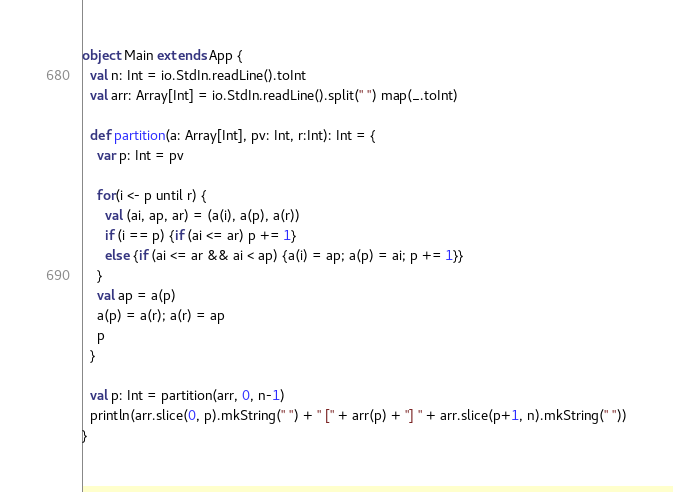Convert code to text. <code><loc_0><loc_0><loc_500><loc_500><_Scala_>object Main extends App {
  val n: Int = io.StdIn.readLine().toInt
  val arr: Array[Int] = io.StdIn.readLine().split(" ") map(_.toInt)

  def partition(a: Array[Int], pv: Int, r:Int): Int = {
    var p: Int = pv

    for(i <- p until r) {
      val (ai, ap, ar) = (a(i), a(p), a(r))
      if (i == p) {if (ai <= ar) p += 1}
      else {if (ai <= ar && ai < ap) {a(i) = ap; a(p) = ai; p += 1}}
    }
    val ap = a(p)
    a(p) = a(r); a(r) = ap
    p
  }

  val p: Int = partition(arr, 0, n-1)
  println(arr.slice(0, p).mkString(" ") + " [" + arr(p) + "] " + arr.slice(p+1, n).mkString(" "))
}</code> 